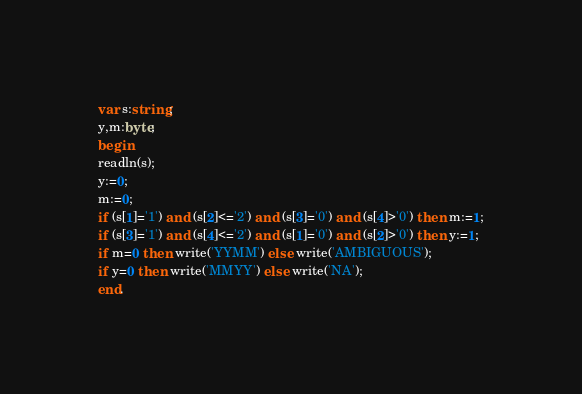Convert code to text. <code><loc_0><loc_0><loc_500><loc_500><_Pascal_>
var s:string;
y,m:byte;
begin
readln(s);
y:=0;
m:=0;
if (s[1]='1') and (s[2]<='2') and (s[3]='0') and (s[4]>'0') then m:=1;
if (s[3]='1') and (s[4]<='2') and (s[1]='0') and (s[2]>'0') then y:=1;
if m=0 then write('YYMM') else write('AMBIGUOUS');
if y=0 then write('MMYY') else write('NA');
end.</code> 